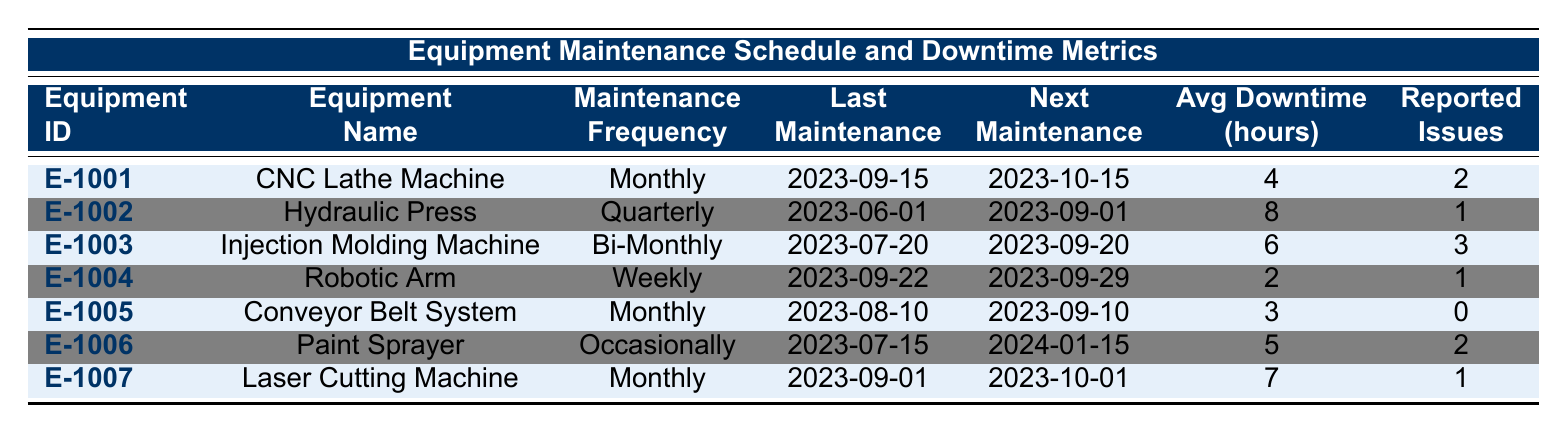What is the maintenance frequency for the CNC Lathe Machine? The table lists the CNC Lathe Machine under the equipment name, and its maintenance frequency is shown in the corresponding column, which states 'Monthly'.
Answer: Monthly When is the next maintenance due for the Hydraulic Press? By referring to the last maintenance date of the Hydraulic Press and looking at the next maintenance due column, it shows the date is '2023-09-01'.
Answer: 2023-09-01 Which equipment has the highest average downtime hours? The average downtime hours for each equipment are compared. The Hydraulic Press has the highest at 8 hours.
Answer: Hydraulic Press How many reported issues does the Injection Molding Machine have? The table shows that the reported issues for the Injection Molding Machine are recorded in its respective column as 3.
Answer: 3 What is the average downtime across all equipment? The average downtime hours can be calculated by summing all individual average downtimes (4 + 8 + 6 + 2 + 3 + 5 + 7 = 35) and dividing by the number of equipment (7), so 35/7 = 5.
Answer: 5 Is the last maintenance date for the Robotic Arm later than that of the Paint Sprayer? Comparing the last maintenance dates: Robotic Arm's last maintenance date is '2023-09-22' and Paint Sprayer's is '2023-07-15'. Since '2023-09-22' is after '2023-07-15', the answer is yes.
Answer: Yes Which equipment has no reported issues, and what is its average downtime? The Conveyor Belt System has 0 reported issues, and its average downtime is listed as 3 hours.
Answer: Conveyor Belt System, 3 hours What is the maintenance frequency of the equipment with the least average downtime? The equipment with the least average downtime is the Robotic Arm with 2 hours, and its maintenance frequency is shown as 'Weekly'.
Answer: Weekly How many pieces of equipment require monthly maintenance? Examining the table, the pieces of equipment that have 'Monthly' as their maintenance frequency are the CNC Lathe Machine, Laser Cutting Machine, and Conveyor Belt System, totaling 3.
Answer: 3 Determine whether the Paint Sprayer is due for maintenance before the next maintenance of the CNC Lathe Machine. The next maintenance due for the CNC Lathe Machine is '2023-10-15', while the Paint Sprayer's next maintenance is due on '2024-01-15', which means the Paint Sprayer is not due for maintenance before the CNC Lathe Machine.
Answer: No 